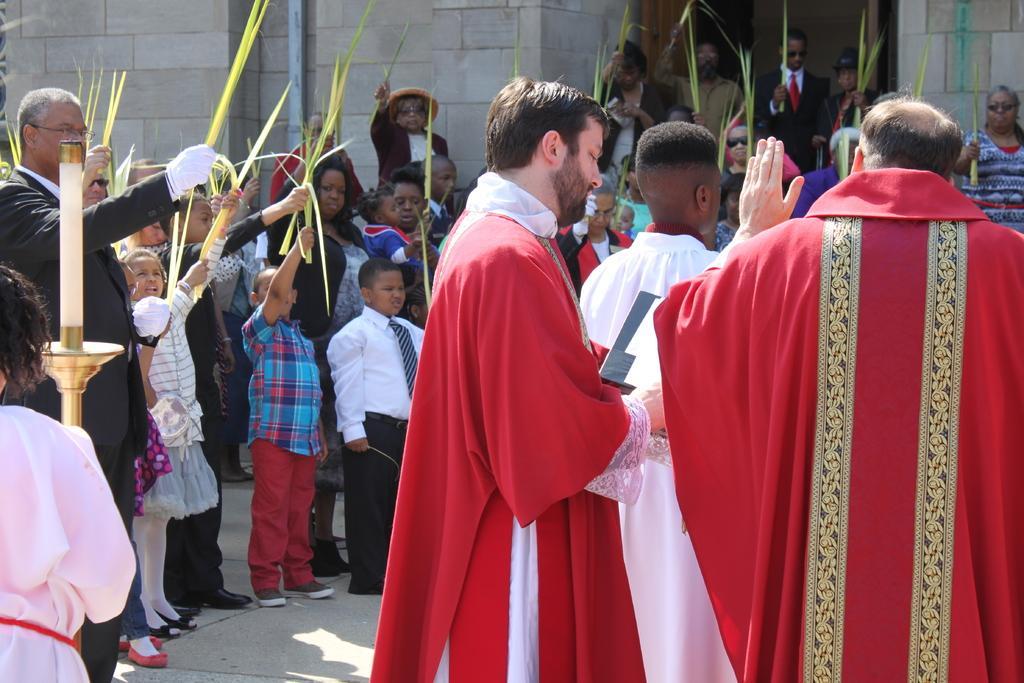How would you summarize this image in a sentence or two? In this image there are group of persons, there are persons holding objects, there are persons truncated towards the left of the image, there are persons truncated towards the right of the image, there is the wall, there is a pipe truncated towards the top of the image. 